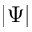Convert formula to latex. <formula><loc_0><loc_0><loc_500><loc_500>\left | \Psi \right |</formula> 